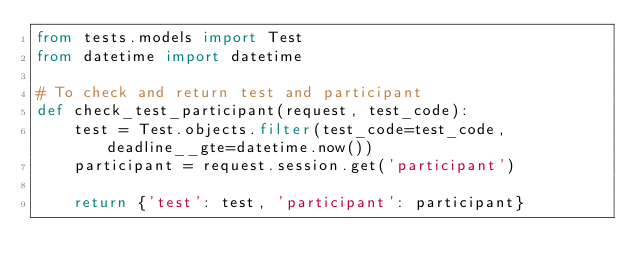<code> <loc_0><loc_0><loc_500><loc_500><_Python_>from tests.models import Test
from datetime import datetime

# To check and return test and participant
def check_test_participant(request, test_code):
    test = Test.objects.filter(test_code=test_code, deadline__gte=datetime.now())
    participant = request.session.get('participant')
    
    return {'test': test, 'participant': participant}</code> 